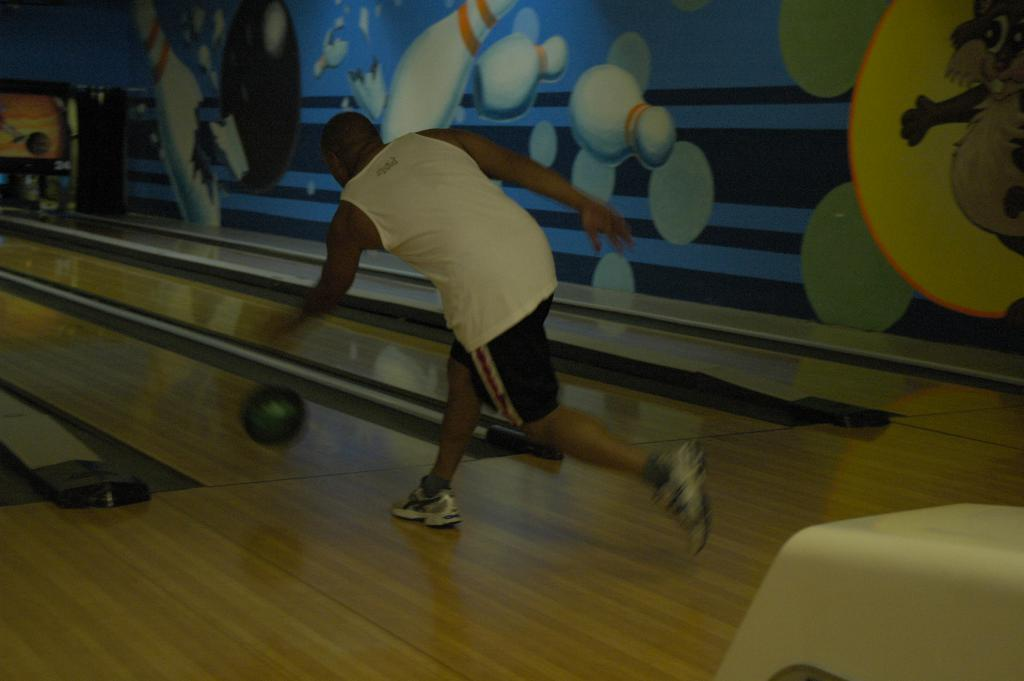What is the man in the image doing? The man in the image is in motion. What object is on the surface in the image? There is a ball on the surface in the image. What can be seen in the background of the image? There is a wall in the background of the image. What is depicted on the wall in the background? There is a painting of bowling pins on the wall in the background. What type of list can be seen being carried by the crowd in the image? There is no crowd present in the image, and therefore no list being carried. 